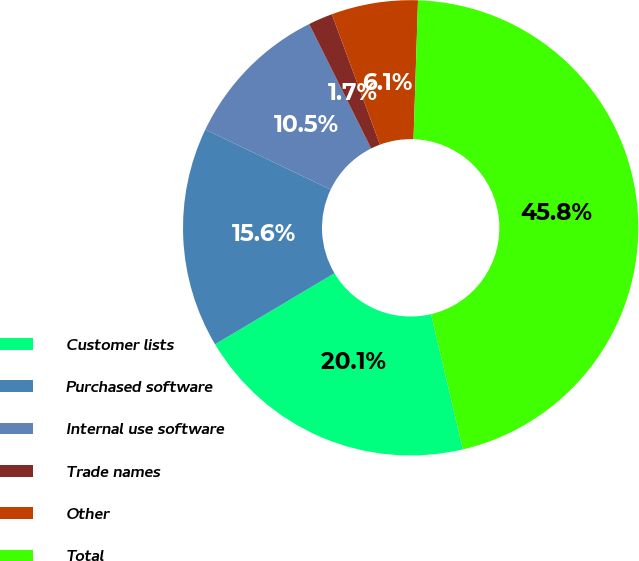<chart> <loc_0><loc_0><loc_500><loc_500><pie_chart><fcel>Customer lists<fcel>Purchased software<fcel>Internal use software<fcel>Trade names<fcel>Other<fcel>Total<nl><fcel>20.14%<fcel>15.65%<fcel>10.54%<fcel>1.73%<fcel>6.14%<fcel>45.8%<nl></chart> 